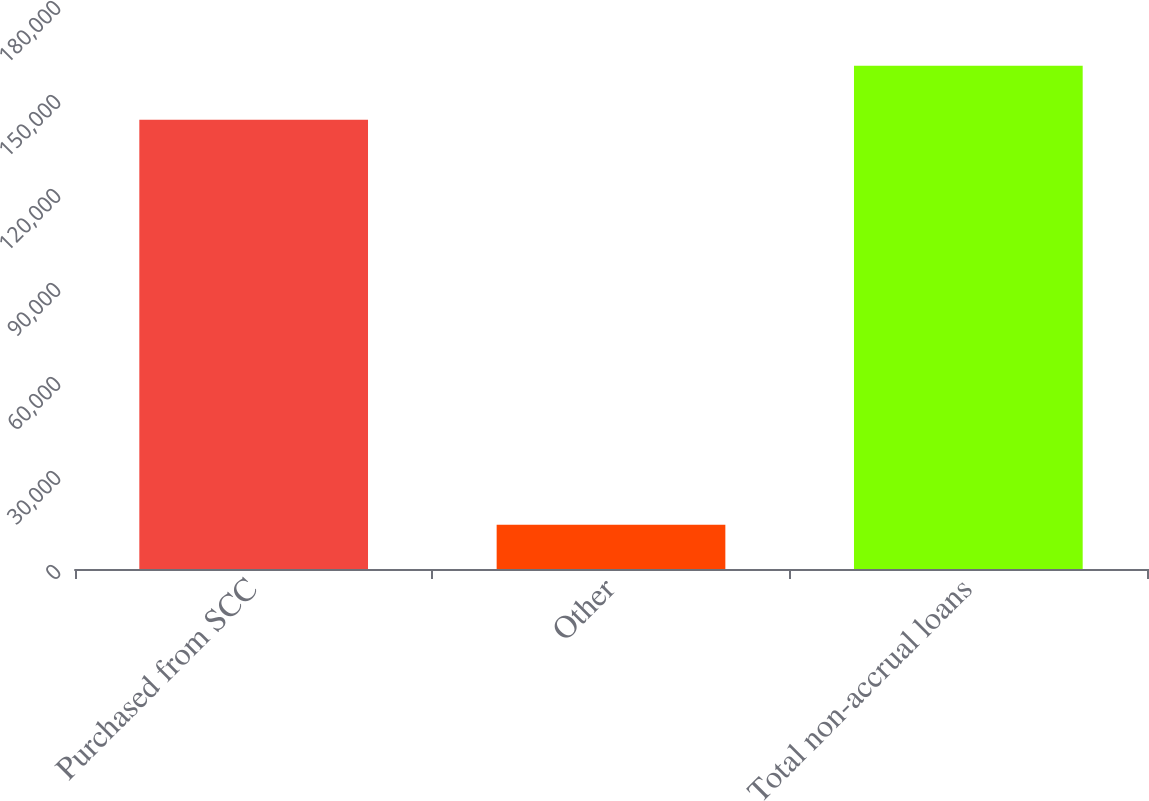<chart> <loc_0><loc_0><loc_500><loc_500><bar_chart><fcel>Purchased from SCC<fcel>Other<fcel>Total non-accrual loans<nl><fcel>143358<fcel>14106<fcel>160642<nl></chart> 